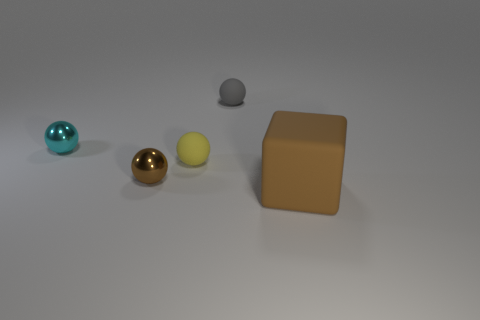What material is the yellow sphere that is the same size as the cyan object?
Keep it short and to the point. Rubber. How many other things are there of the same material as the cube?
Your answer should be very brief. 2. There is a tiny yellow rubber object; how many large rubber blocks are left of it?
Ensure brevity in your answer.  0. How many spheres are either big rubber objects or small gray objects?
Provide a short and direct response. 1. There is a thing that is both in front of the yellow object and to the right of the brown sphere; what size is it?
Ensure brevity in your answer.  Large. How many other things are the same color as the block?
Your answer should be very brief. 1. Does the small gray thing have the same material as the tiny thing in front of the tiny yellow matte ball?
Provide a short and direct response. No. What number of objects are either small rubber objects in front of the gray matte thing or big purple cylinders?
Keep it short and to the point. 1. What shape is the thing that is to the right of the small yellow thing and in front of the tiny gray rubber sphere?
Give a very brief answer. Cube. Are there any other things that have the same size as the block?
Make the answer very short. No. 